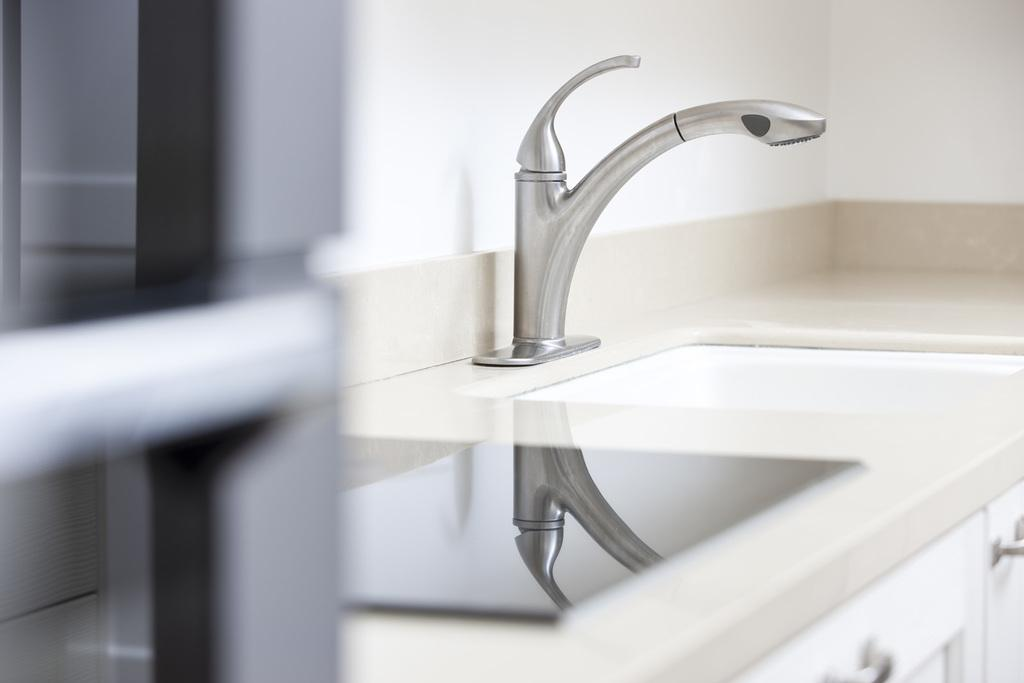What type of fixture is present in the image for washing hands or dishes? There is a sink in the image. What is used to control the flow of water in the sink? There is a tap in the image. What type of storage is available in the image? There is a cupboard in the image. What surface is available for preparing food or placing items? There is a countertop in the image. What color is the wall in the image? The wall in the image is white. How many feet are visible in the image? There are no feet visible in the image. What type of amusement can be seen in the image? There is no amusement present in the image; it features a sink, tap, cupboard, countertop, and a white wall. 